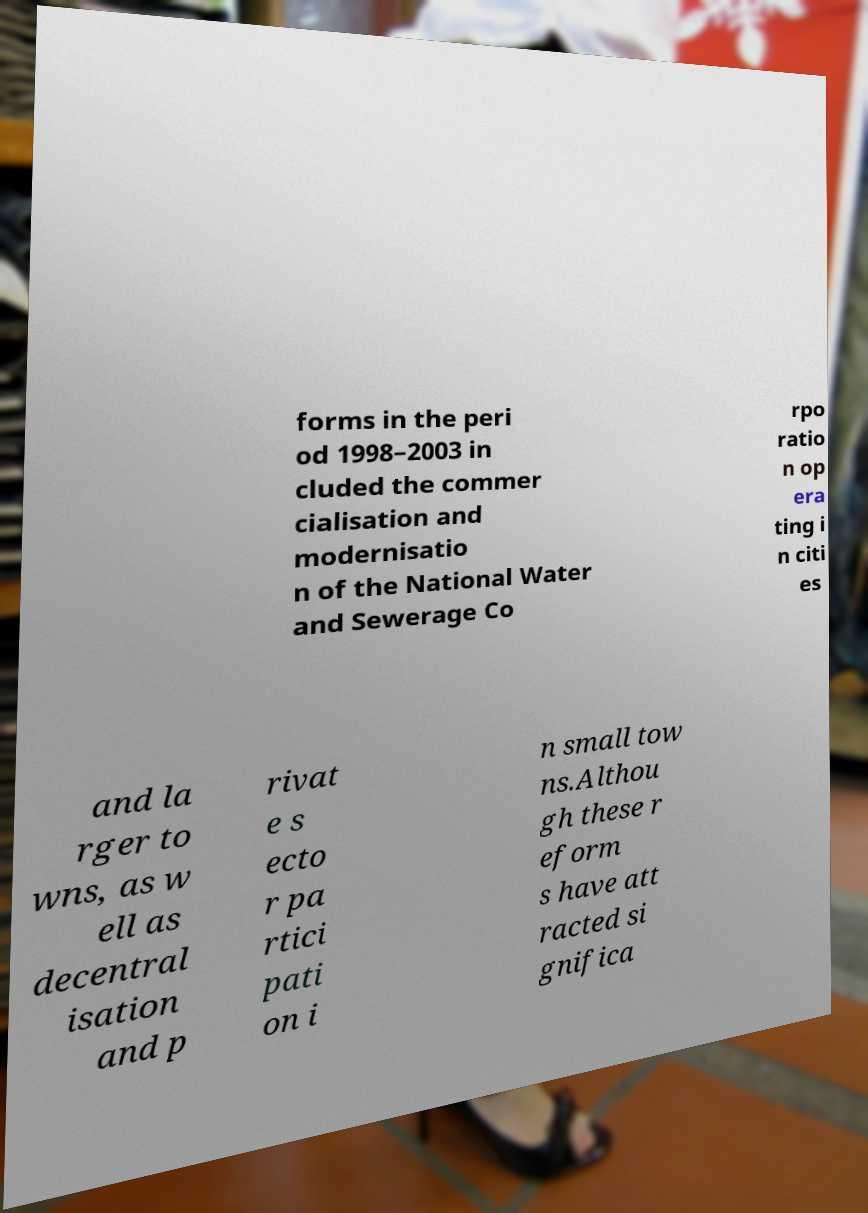Please identify and transcribe the text found in this image. forms in the peri od 1998–2003 in cluded the commer cialisation and modernisatio n of the National Water and Sewerage Co rpo ratio n op era ting i n citi es and la rger to wns, as w ell as decentral isation and p rivat e s ecto r pa rtici pati on i n small tow ns.Althou gh these r eform s have att racted si gnifica 